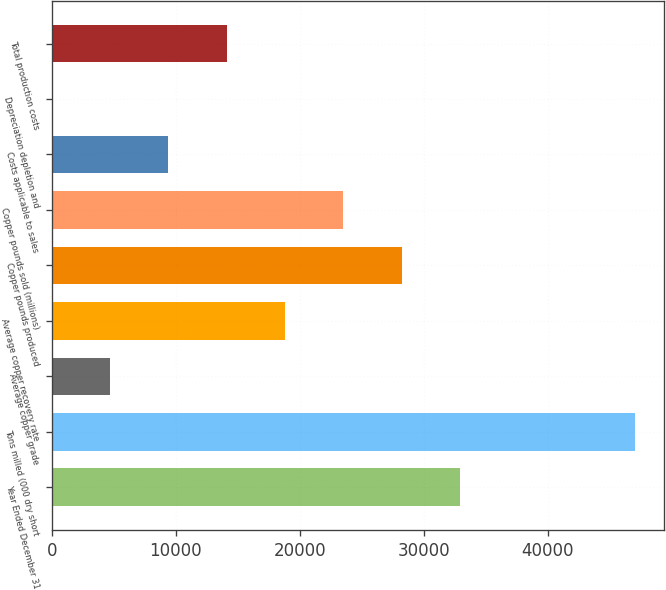Convert chart. <chart><loc_0><loc_0><loc_500><loc_500><bar_chart><fcel>Year Ended December 31<fcel>Tons milled (000 dry short<fcel>Average copper grade<fcel>Average copper recovery rate<fcel>Copper pounds produced<fcel>Copper pounds sold (millions)<fcel>Costs applicable to sales<fcel>Depreciation depletion and<fcel>Total production costs<nl><fcel>32918.2<fcel>47026<fcel>4702.73<fcel>18810.5<fcel>28215.7<fcel>23513.1<fcel>9405.31<fcel>0.15<fcel>14107.9<nl></chart> 